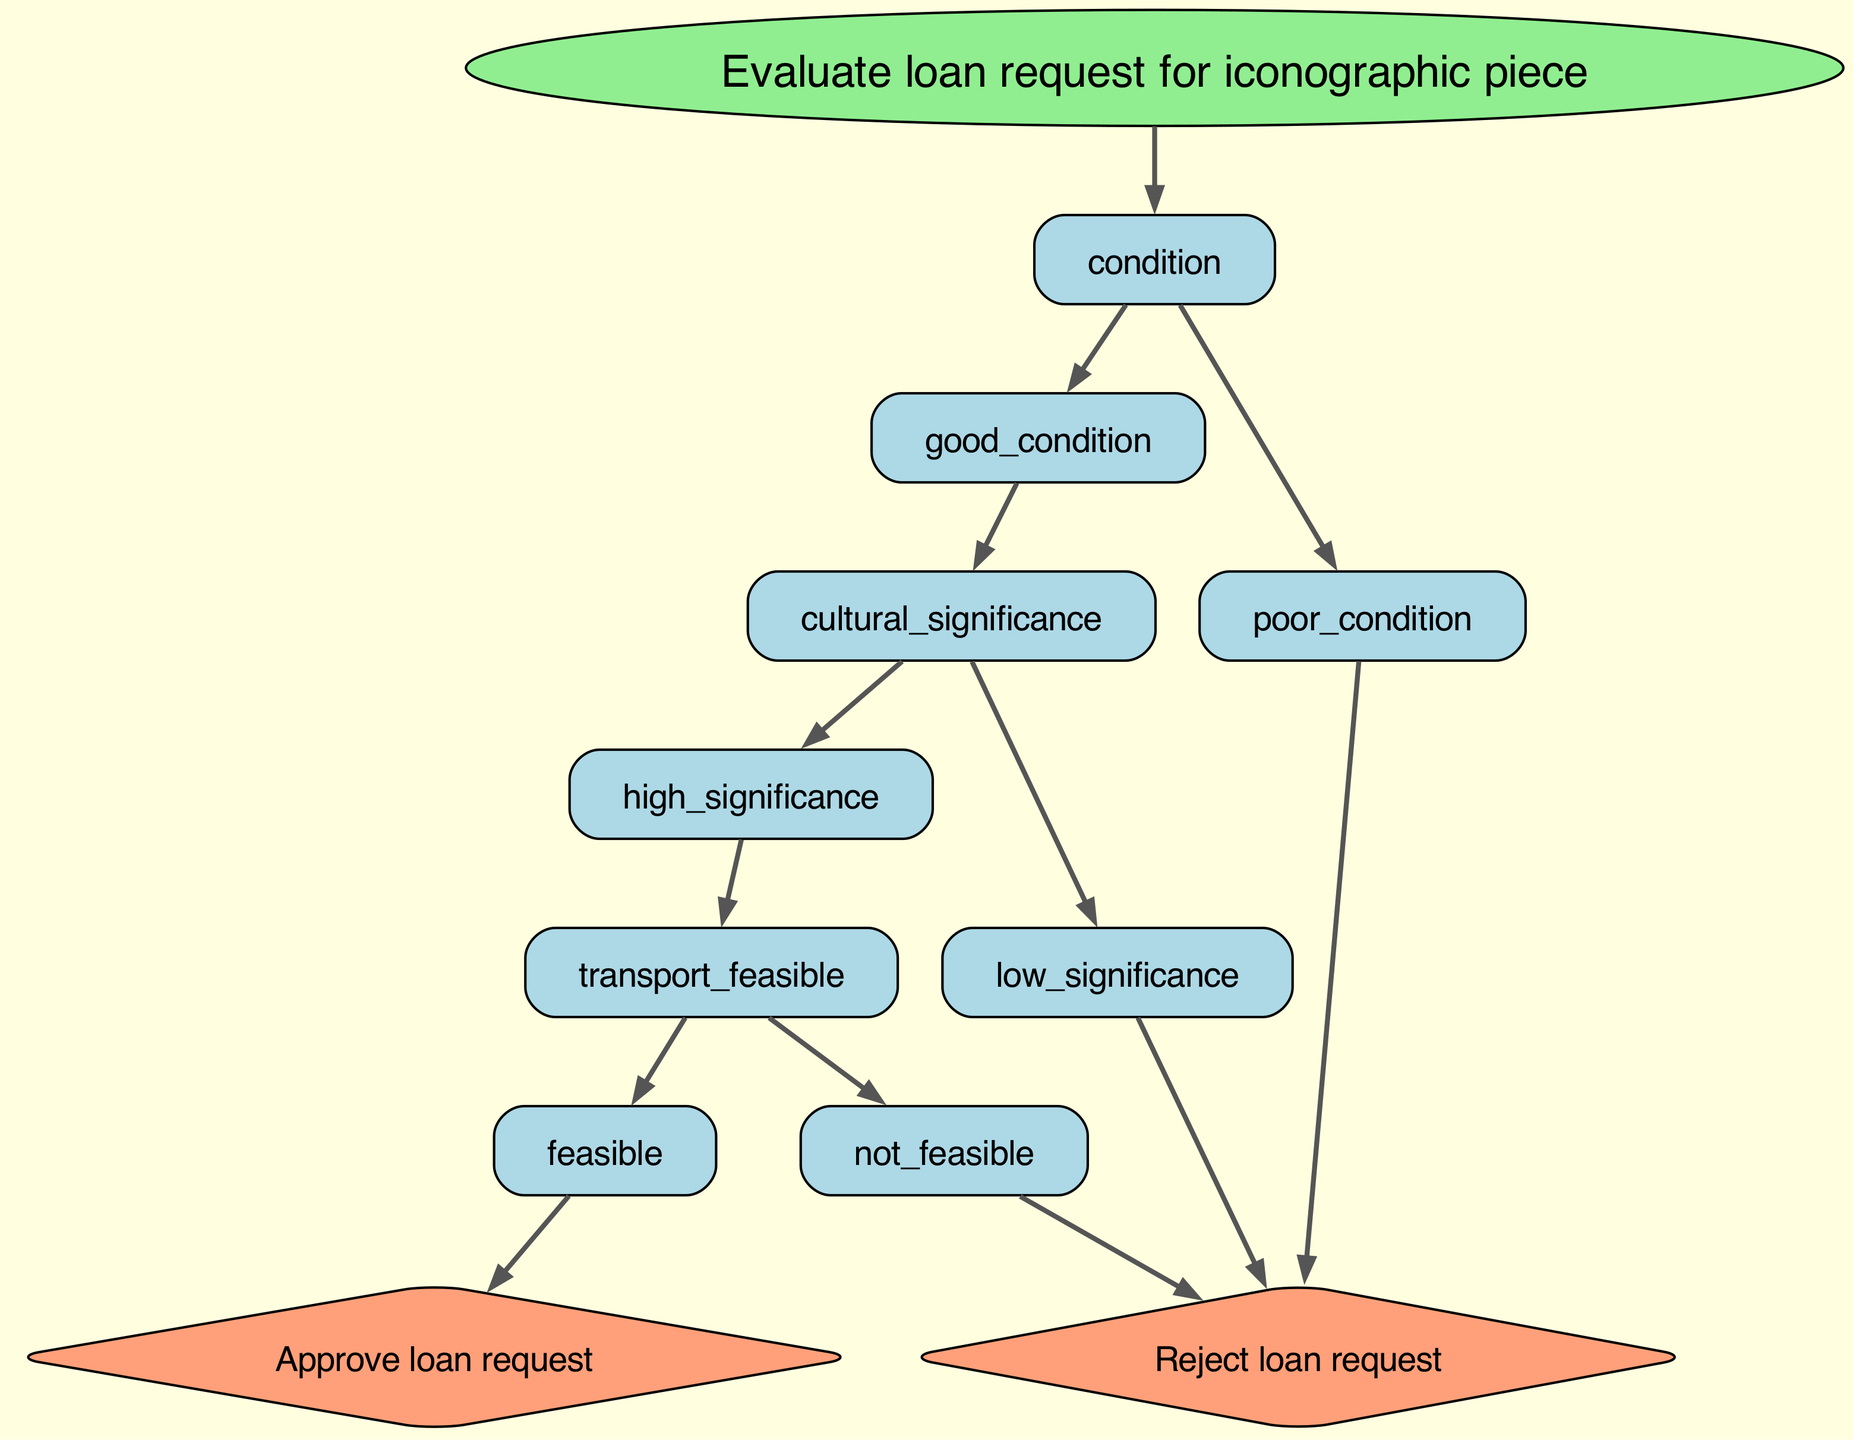What is the root node of the decision tree? The root node is labeled "Evaluate loan request for iconographic piece," which signifies the main decision-making process initiated in the diagram.
Answer: Evaluate loan request for iconographic piece How many main conditions are evaluated in the decision tree? There are two main conditions evaluated: whether the piece is in good condition or not, highlighting the importance of its physical state in loan decisions.
Answer: 2 What happens if the piece is in poor condition? According to the diagram, if the piece is in poor condition, the loan request is rejected immediately, indicating that condition is crucial for loan approval.
Answer: Reject loan request If the piece is in good condition but has low cultural significance, what is the outcome? If the piece is in good condition but has low cultural significance, the loan request is also rejected. This shows that high cultural significance is a requirement for approval in good condition pieces.
Answer: Reject loan request What must be true for the loan request to be approved? For the loan request to be approved, the piece must be in good condition, have high cultural significance, and the transport must be feasible, demonstrating the multiple criteria needed for loan approval.
Answer: Approve loan request What occurs if the piece has high cultural significance but transport is not feasible? In this case, if the piece has high cultural significance but transport is not feasible, the loan request is rejected, emphasizing that feasibility is an essential factor regardless of cultural worth.
Answer: Reject loan request What type of node represents the decision to approve or reject a loan request? The final decisions to approve or reject a loan request are represented as terminal nodes (leaves) in the decision tree, which indicate end outcomes based on the evaluated conditions.
Answer: Terminal nodes Which pathway leads to the approval of the loan request? The pathway leading to loan approval starts with the piece being in good condition, then having high cultural significance, and finally confirming feasible transport, combining all necessary conditions successfully.
Answer: Good condition → High significance → Feasible transport → Approve loan request 